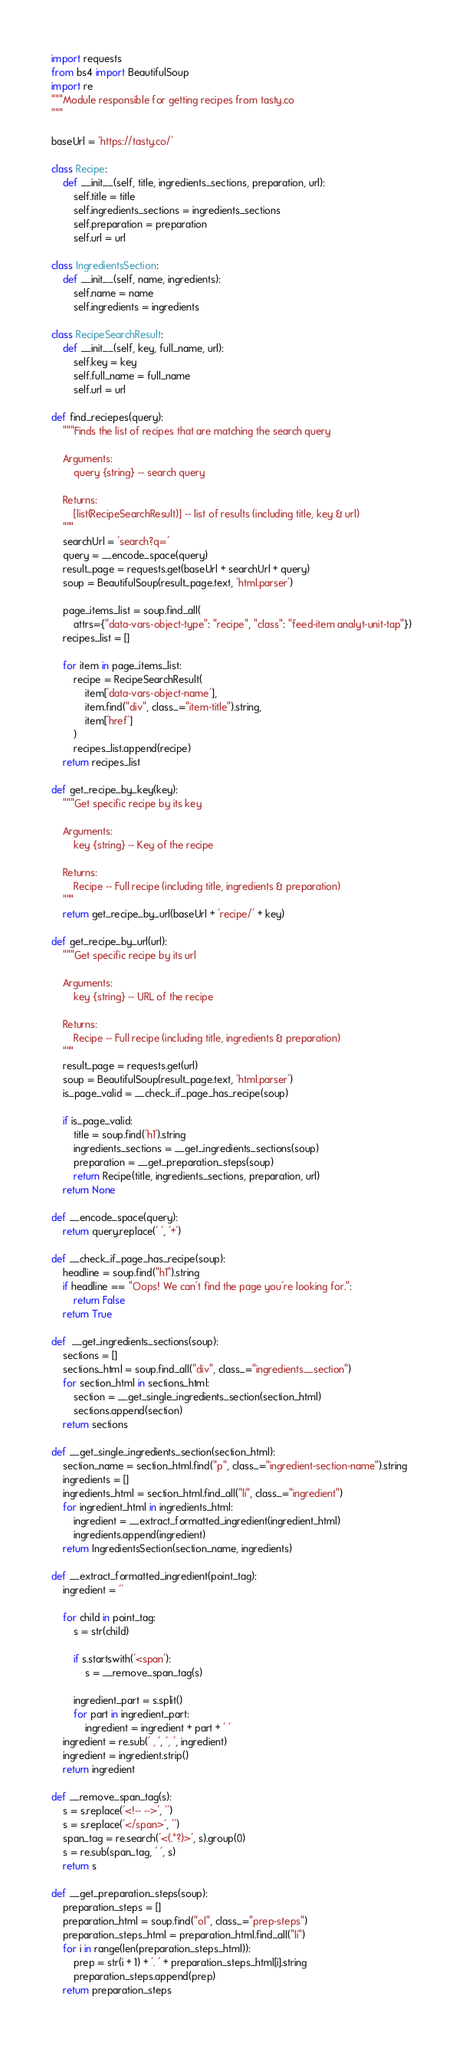<code> <loc_0><loc_0><loc_500><loc_500><_Python_>import requests
from bs4 import BeautifulSoup
import re
"""Module responsible for getting recipes from tasty.co
"""

baseUrl = 'https://tasty.co/'

class Recipe: 
    def __init__(self, title, ingredients_sections, preparation, url):
        self.title = title
        self.ingredients_sections = ingredients_sections
        self.preparation = preparation
        self.url = url

class IngredientsSection:
    def __init__(self, name, ingredients):
        self.name = name
        self.ingredients = ingredients

class RecipeSearchResult:
    def __init__(self, key, full_name, url):
        self.key = key
        self.full_name = full_name
        self.url = url

def find_reciepes(query):
    """Finds the list of recipes that are matching the search query
    
    Arguments:
        query {string} -- search query
    
    Returns:
        [list(RecipeSearchResult)] -- list of results (including title, key & url)
    """
    searchUrl = 'search?q='
    query = __encode_space(query)
    result_page = requests.get(baseUrl + searchUrl + query)
    soup = BeautifulSoup(result_page.text, 'html.parser')

    page_items_list = soup.find_all(
        attrs={"data-vars-object-type": "recipe", "class": "feed-item analyt-unit-tap"})
    recipes_list = []

    for item in page_items_list:
        recipe = RecipeSearchResult(
            item['data-vars-object-name'],
            item.find("div", class_="item-title").string,
            item['href']
        )
        recipes_list.append(recipe)
    return recipes_list

def get_recipe_by_key(key):
    """Get specific recipe by its key
    
    Arguments:
        key {string} -- Key of the recipe
    
    Returns:
        Recipe -- Full recipe (including title, ingredients & preparation)
    """
    return get_recipe_by_url(baseUrl + 'recipe/' + key)

def get_recipe_by_url(url):
    """Get specific recipe by its url
    
    Arguments:
        key {string} -- URL of the recipe
    
    Returns:
        Recipe -- Full recipe (including title, ingredients & preparation)
    """
    result_page = requests.get(url)
    soup = BeautifulSoup(result_page.text, 'html.parser')
    is_page_valid = __check_if_page_has_recipe(soup)

    if is_page_valid:
        title = soup.find('h1').string
        ingredients_sections = __get_ingredients_sections(soup)
        preparation = __get_preparation_steps(soup)
        return Recipe(title, ingredients_sections, preparation, url)
    return None

def __encode_space(query):
    return query.replace(' ', '+')

def __check_if_page_has_recipe(soup):
    headline = soup.find("h1").string
    if headline == "Oops! We can't find the page you're looking for.":
        return False
    return True

def  __get_ingredients_sections(soup):
    sections = []
    sections_html = soup.find_all("div", class_="ingredients__section")
    for section_html in sections_html:
        section = __get_single_ingredients_section(section_html)
        sections.append(section)
    return sections

def __get_single_ingredients_section(section_html):
    section_name = section_html.find("p", class_="ingredient-section-name").string
    ingredients = []
    ingredients_html = section_html.find_all("li", class_="ingredient")
    for ingredient_html in ingredients_html:
        ingredient = __extract_formatted_ingredient(ingredient_html)
        ingredients.append(ingredient)
    return IngredientsSection(section_name, ingredients)

def __extract_formatted_ingredient(point_tag):
    ingredient = ''
    
    for child in point_tag:
        s = str(child)
        
        if s.startswith('<span'):
            s = __remove_span_tag(s)
        
        ingredient_part = s.split()
        for part in ingredient_part:
            ingredient = ingredient + part + ' '
    ingredient = re.sub(' , ', ', ', ingredient)
    ingredient = ingredient.strip()
    return ingredient

def __remove_span_tag(s):
    s = s.replace('<!-- -->', '')
    s = s.replace('</span>', '')
    span_tag = re.search('<(.*?)>', s).group(0)
    s = re.sub(span_tag, ' ', s)
    return s

def __get_preparation_steps(soup):
    preparation_steps = []
    preparation_html = soup.find("ol", class_="prep-steps")
    preparation_steps_html = preparation_html.find_all("li")
    for i in range(len(preparation_steps_html)):
        prep = str(i + 1) + '. ' + preparation_steps_html[i].string
        preparation_steps.append(prep)
    return preparation_steps</code> 